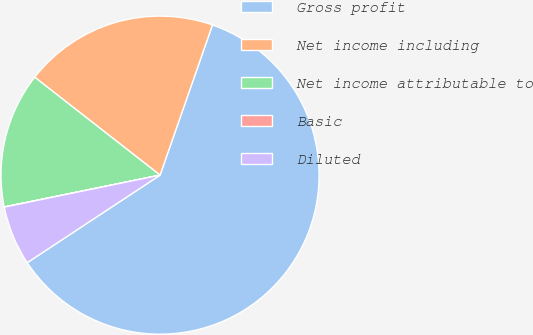Convert chart to OTSL. <chart><loc_0><loc_0><loc_500><loc_500><pie_chart><fcel>Gross profit<fcel>Net income including<fcel>Net income attributable to<fcel>Basic<fcel>Diluted<nl><fcel>60.38%<fcel>19.79%<fcel>13.76%<fcel>0.02%<fcel>6.05%<nl></chart> 